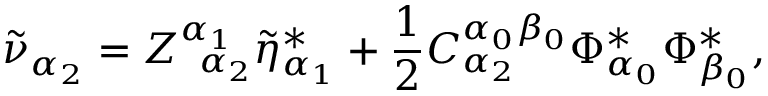<formula> <loc_0><loc_0><loc_500><loc_500>\tilde { \nu } _ { \alpha _ { 2 } } = Z _ { \, \alpha _ { 2 } } ^ { \alpha _ { 1 } } \tilde { \eta } _ { \alpha _ { 1 } } ^ { * } + \frac { 1 } { 2 } C _ { \alpha _ { 2 } } ^ { \alpha _ { 0 } \beta _ { 0 } } \Phi _ { \alpha _ { 0 } } ^ { * } \Phi _ { \beta _ { 0 } } ^ { * } ,</formula> 